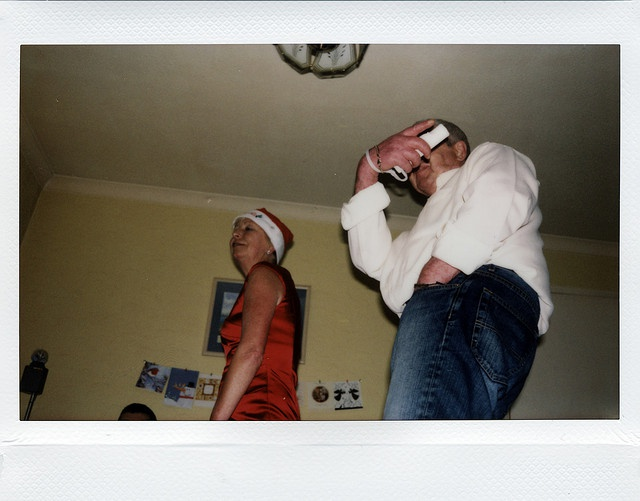Describe the objects in this image and their specific colors. I can see people in lightgray, black, darkgray, and gray tones, people in lightgray, maroon, black, and brown tones, remote in lightgray, darkgray, and black tones, and people in black, darkgreen, and lightgray tones in this image. 